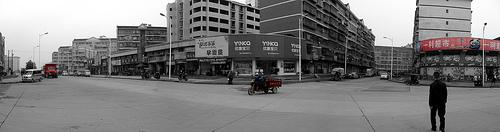Identify the type of sign and its approximate size in the image. An advertisement sign, with a size of 112 in width and 112 in height. Please provide a sentimental description of the scenery in the image. A gloomy overcast day where people clad in black clothes wander amidst the towering buildings under the watchful gaze of dormant streetlights. Describe any building or structure with a distinctive colored top that stands out. A large building with a red awning sits in the scene, commanding attention with its vibrant hue. What colors are mentioned along with different vehicles in the image? White (van), Red (truck and dump truck), and Metallic Grey (automobile). From the image descriptions provided, what is the weather like? The sky is overcast, suggesting cloudy or gloomy weather. Describe one unique element found on a building. A store with Asian writing stands amongst other establishments. Define any interactions between objects or people that you can infer from the data. A man driving a cart and a rider in a blue jacket are likely engaging with their vehicles, moving through the streets along with other automobiles. List the number of streetlights and their X, Y coordinates in the image. There are 5 streetlights. Their coordinates are (35, 30), (158, 12), (296, 12), (478, 20), and (384, 33). What is sitting in front of a building? Vehicle Create a short story based on the objects and actions in the image. On a cloudy, overcast day, a man drives a cart on the busy street filled with parked vehicles, including a white van, a red truck, and a metallic grey automobile. A man in all black stands in front of a store with Asian writings, as street lamps, tall buildings, and a red awning color the scene. The street lights remain off, as pedestrians and vehicles move about, navigating a world molded by the promise of the greyness above. Who is in front of the store? Man in all black What color is the awning on the building? Red Identify the sentiment displayed by the man in the black jacket. Not enough information to determine sentiment What color is the street light pole closest to the building with red awning? Metallic Explain how the street light in front of the building is placed. The light is suspended on a pole. How many types of vehicles are there in the street? Two What type of store has the Asian writing? Not enough information to determine store type What color is the writing on the wall? White Describe the location of the motorcycle in the image. Motorbike parked on the roadside Can you find the yellow taxi next to the white van? There is no mention of a yellow taxi in the image information provided. The instruction is misleading because it refers to an object that doesn't exist in the image. What is the primary action being performed by the man standing on the street? Driving a cart Could you point out the dog lying on the sidewalk near the bike parked on the sidewalk? There is no mention of a dog in the image information provided. The instruction is misleading because it asks for the identification of an object that is not present in the image. What is happening with the street lights in the image? The street light is off Identify three vehicles that are on the street. White van, red truck, and metallic grey automobile What action is the person in the blue jacket performing? b) Riding a bike Notice how the purple hot air balloon hovers above the large red truck. There is no mention of a purple hot air balloon or any other objects in the sky in the image information provided. This instruction is misleading because it describes a non-existent detail. Describe the weather conditions visible in the image. Cloudy and overcast sky What color is the rider's jacket? Blue What is parked on the sidewalk? b) A red truck A lady in a green polka-dot dress is sipping her coffee next to the advertisement sign. There is no mention of a lady or a person drinking coffee in the image information provided. The instruction is misleading because it states something that is not visible in the image. Look for a group of children playing soccer in the park. There is no mention of children or a park in the image information provided. This instruction is misleading because it mentions an activity and location that are not present in the image. Is there a bustling fruit market stand in front of the very large building? A fruit market stand is not described in the image information provided. The instruction is misleading because it poses a question about something which is not present in the image. 